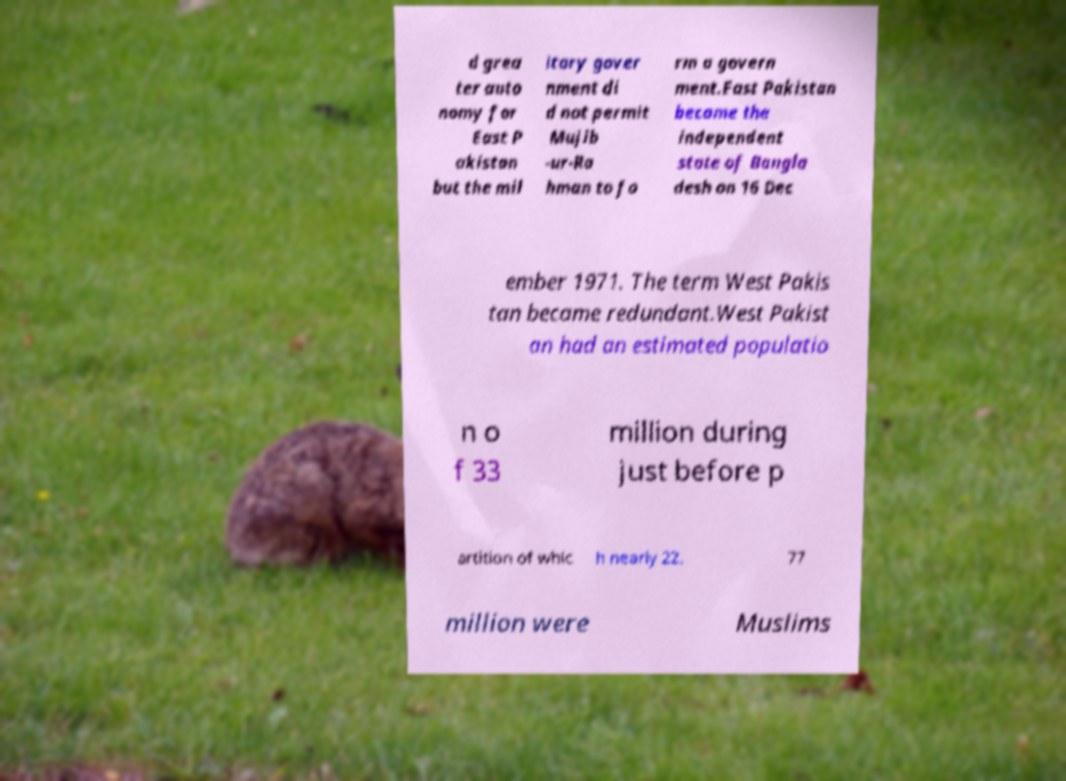I need the written content from this picture converted into text. Can you do that? d grea ter auto nomy for East P akistan but the mil itary gover nment di d not permit Mujib -ur-Ra hman to fo rm a govern ment.East Pakistan became the independent state of Bangla desh on 16 Dec ember 1971. The term West Pakis tan became redundant.West Pakist an had an estimated populatio n o f 33 million during just before p artition of whic h nearly 22. 77 million were Muslims 